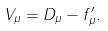Convert formula to latex. <formula><loc_0><loc_0><loc_500><loc_500>V _ { \mu } = D _ { \mu } - f _ { \mu } ^ { \prime } .</formula> 